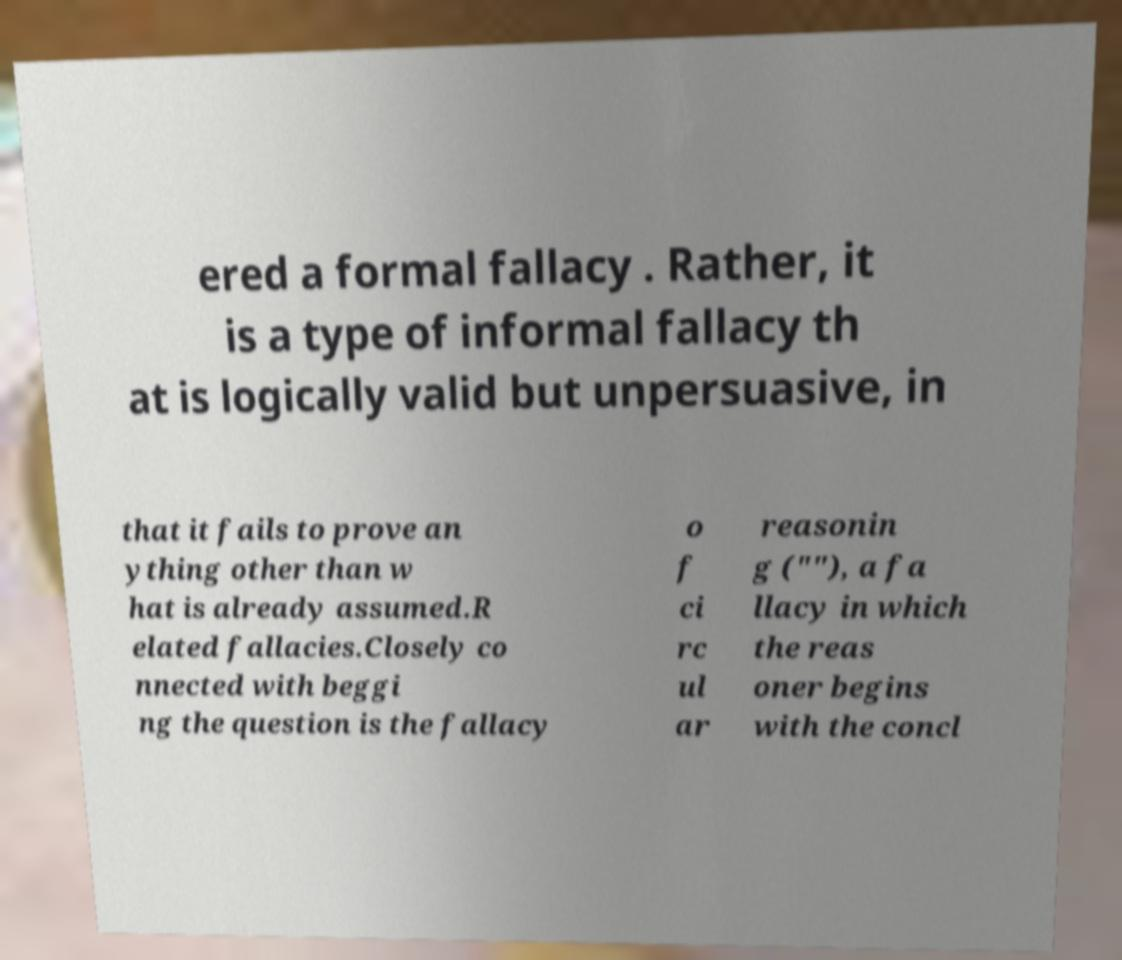Could you assist in decoding the text presented in this image and type it out clearly? ered a formal fallacy . Rather, it is a type of informal fallacy th at is logically valid but unpersuasive, in that it fails to prove an ything other than w hat is already assumed.R elated fallacies.Closely co nnected with beggi ng the question is the fallacy o f ci rc ul ar reasonin g (""), a fa llacy in which the reas oner begins with the concl 